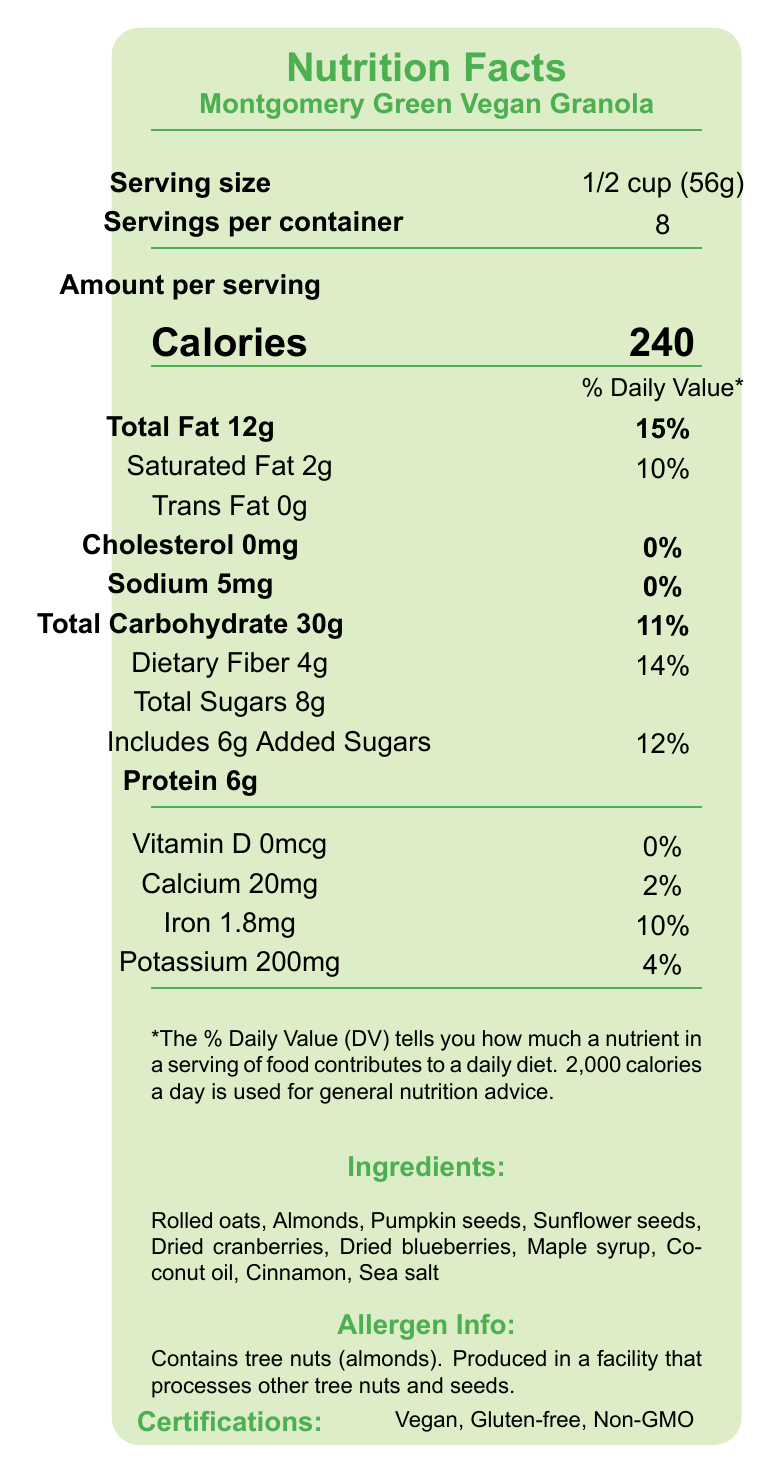what is the product name? The product name is listed at the top of the nutrition facts label, right under the title "Nutrition Facts".
Answer: Montgomery Green Vegan Granola how many calories are there per serving? The label specifies that there are 240 calories per serving.
Answer: 240 how much saturated fat is there in one serving? The amount of saturated fat per serving is indicated to be 2g.
Answer: 2g what are the total sugars and added sugars per serving? The label shows 8g for total sugars and within it, 6g are added sugars.
Answer: Total sugars are 8g, and added sugars are 6g what is the serving size? The serving size is specified to be 1/2 cup (56g).
Answer: 1/2 cup (56g) which of the following nutrients are present in amounts contributing 0% to the daily value? A. Sodium B. Cholesterol C. Vitamin D D. Potassium Cholesterol and Vitamin D both contribute 0% to the daily value as per the label.
Answer: B and C what percent daily value of dietary fiber does one serving provide? A. 10% B. 11% C. 14% D. 15% The dietary fiber in one serving provides 14% of the daily value.
Answer: C is there any cholesterol in this granola? The label shows that the cholesterol amount is 0mg, indicating no cholesterol.
Answer: No what are the main certifications of this product? The specified certifications on the label are Vegan, Gluten-free, and Non-GMO.
Answer: Vegan, Gluten-free, Non-GMO what are the ingredients of the granola? The ingredients are listed on the label in detail.
Answer: Rolled oats, Almonds, Pumpkin seeds, Sunflower seeds, Dried cranberries, Dried blueberries, Maple syrup, Coconut oil, Cinnamon, Sea salt does this product contain tree nuts? The allergen info section clearly states that the product contains tree nuts (almonds).
Answer: Yes is there a significant amount of sodium in the granola? The sodium amount is only 5mg, which is 0% of the daily value, indicating it is not significant.
Answer: No does the eco-friendly packaging contribute to the sustainability note? The sustainability note mentions reducing the carbon footprint through local sourcing, and the eco-friendly, compostable packaging contributes to this ethos.
Answer: Yes is this product suitable for a gluten-free diet? The label includes a certification that the product is gluten-free.
Answer: Yes explain the sustainability practices of this product The label details indicate that all ingredients are locally sourced, and the packaging is eco-friendly, highlighting the product's sustainability.
Answer: The product is sourced from Montgomery County farmers’ markets, supporting local farmers and reducing carbon footprint through local sourcing. The packaging is also eco-friendly and made from compostable plant-based materials. name a mineral found in the granola and its amount per serving. The label lists iron as one of the minerals, with its amount per serving being 1.8mg.
Answer: Iron, 1.8mg how many servings are there in a container? The label indicates that there are 8 servings per container.
Answer: 8 what are the storage instructions for the granola? The document provides specific storage instructions indicating where to store and the ideal consumption period after opening.
Answer: Store in a cool, dry place. Consume within 3 weeks of opening for best freshness. what is the total carbohydrate content per serving? The total carbohydrate amount per serving is listed as 30g.
Answer: 30g can the source of the ingredients be determined from the document? The label states that all ingredients are sourced from Montgomery County farmers’ markets.
Answer: Yes does the granola contain any artificial sweeteners? The label does not provide information on whether the sweeteners used are artificial, it lists "Maple syrup" as the sweetener but does not discuss any other sweeteners.
Answer: Cannot be determined 